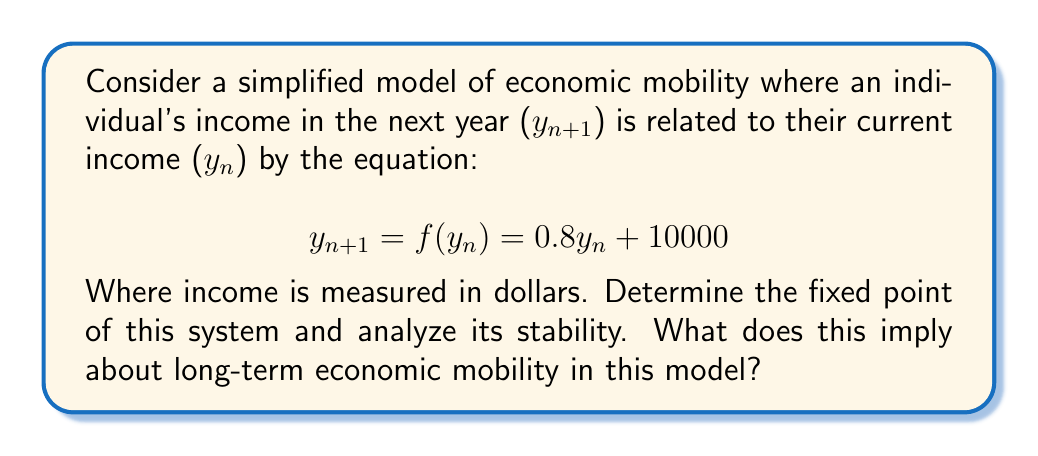Could you help me with this problem? 1. To find the fixed point, we set $y_{n+1} = y_n = y^*$:

   $$y^* = 0.8y^* + 10000$$

2. Solve for $y^*$:
   $$y^* - 0.8y^* = 10000$$
   $$0.2y^* = 10000$$
   $$y^* = 50000$$

3. To analyze stability, we examine the derivative of $f(y)$ at the fixed point:

   $$f'(y) = 0.8$$

   $$|f'(y^*)| = |0.8| < 1$$

4. Since $|f'(y^*)| < 1$, this is a stable fixed point (attracting).

5. Interpretation: In this model, regardless of the initial income, an individual's income will converge to $50,000 over time. The stability of the fixed point suggests limited long-term economic mobility, as incomes tend to gravitate towards this value.

6. The coefficient 0.8 represents some persistence of income inequality (80% of current income affects next year's income), while the constant term $10,000 represents factors that promote mobility (e.g., social programs, minimum wage).
Answer: Fixed point: $50,000; stable. Limited long-term mobility. 